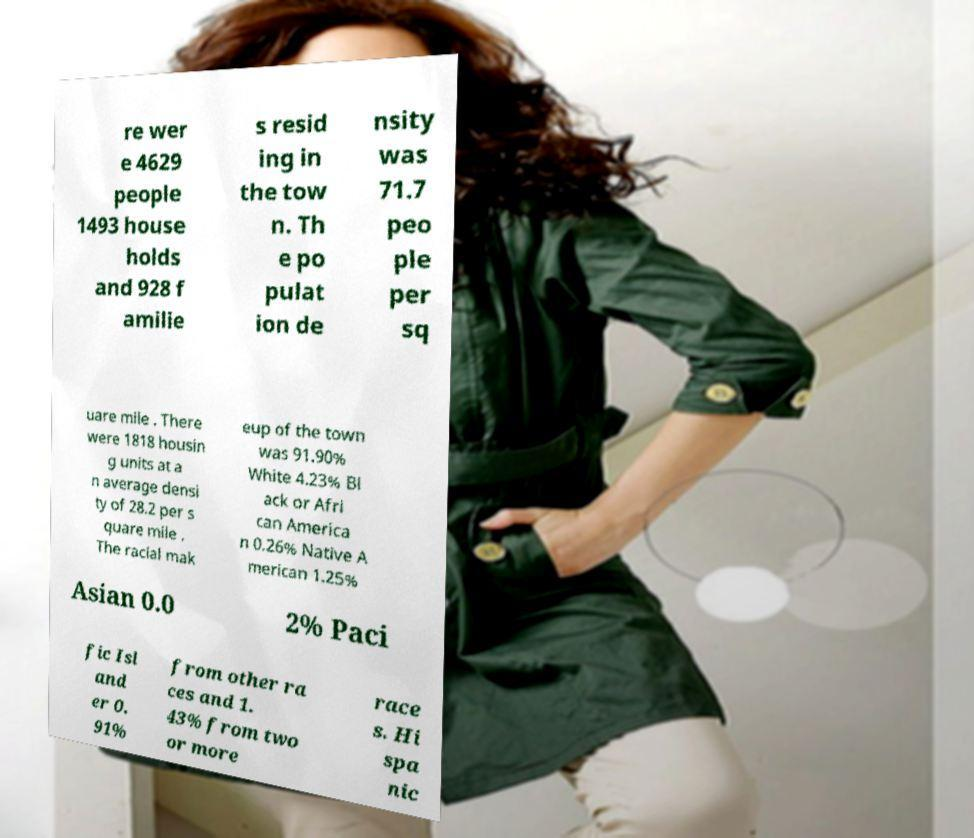I need the written content from this picture converted into text. Can you do that? re wer e 4629 people 1493 house holds and 928 f amilie s resid ing in the tow n. Th e po pulat ion de nsity was 71.7 peo ple per sq uare mile . There were 1818 housin g units at a n average densi ty of 28.2 per s quare mile . The racial mak eup of the town was 91.90% White 4.23% Bl ack or Afri can America n 0.26% Native A merican 1.25% Asian 0.0 2% Paci fic Isl and er 0. 91% from other ra ces and 1. 43% from two or more race s. Hi spa nic 